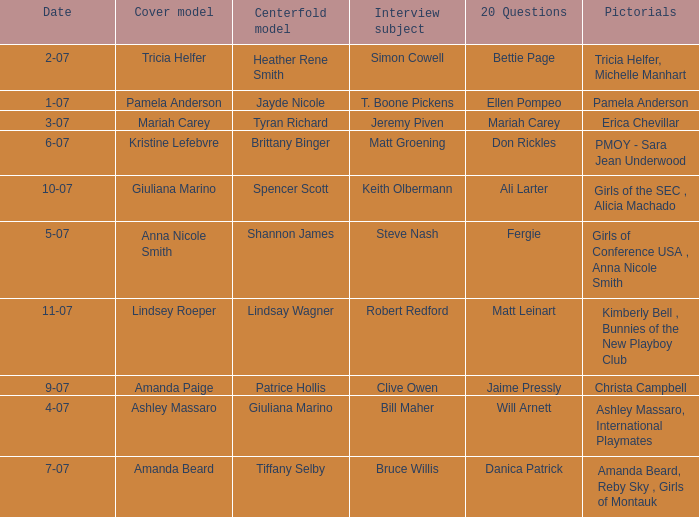List the pictorals from issues when lindsey roeper was the cover model. Kimberly Bell , Bunnies of the New Playboy Club. 